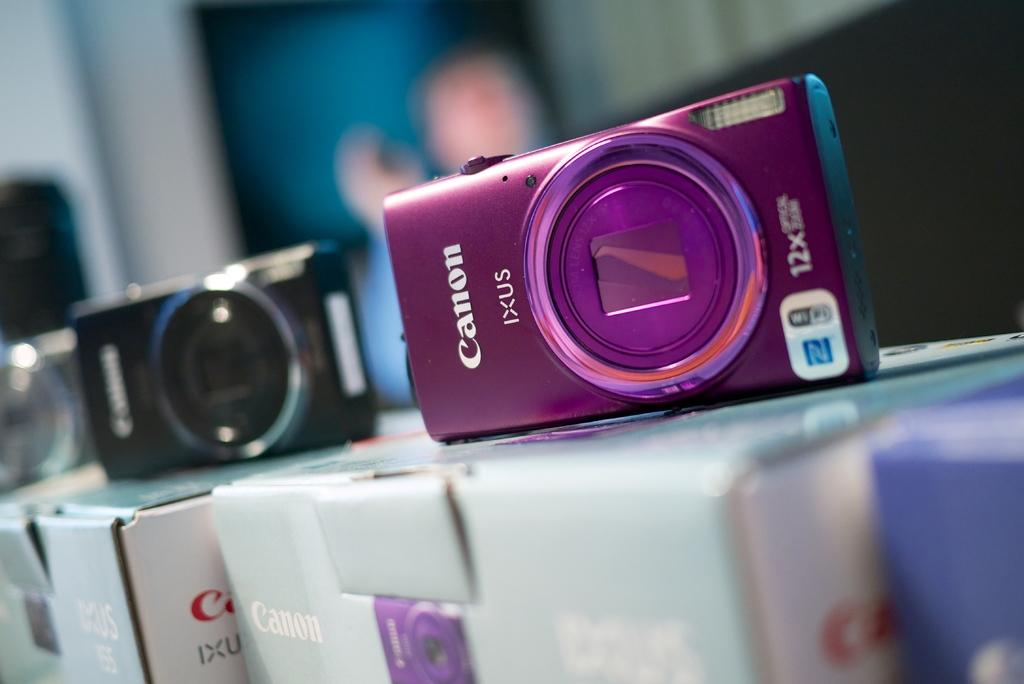<image>
Provide a brief description of the given image. A purple Canon camera on top of box sitting next to a black one that is also on top of a box. 